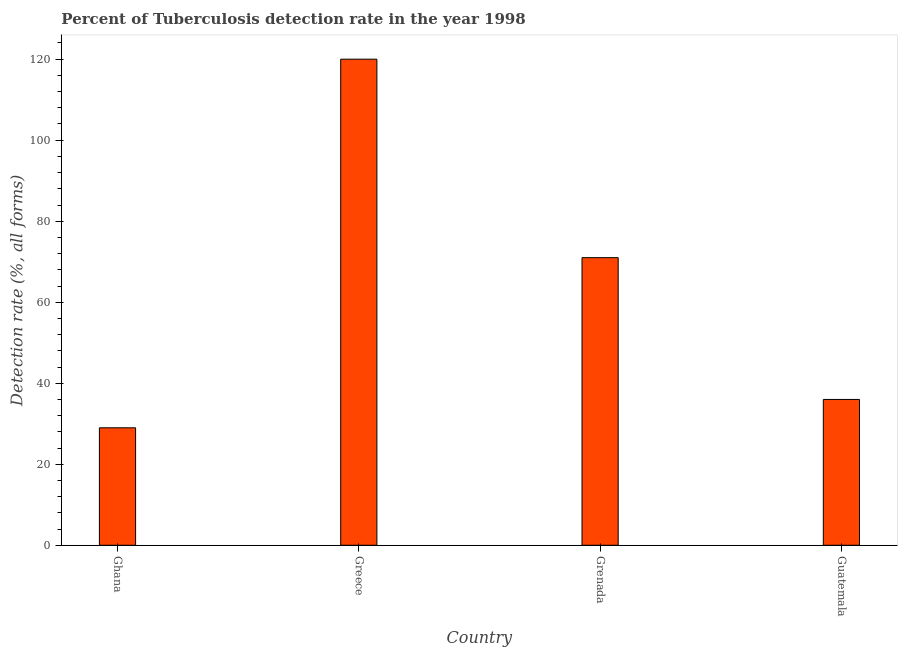Does the graph contain grids?
Your answer should be very brief. No. What is the title of the graph?
Your response must be concise. Percent of Tuberculosis detection rate in the year 1998. What is the label or title of the Y-axis?
Offer a terse response. Detection rate (%, all forms). What is the detection rate of tuberculosis in Greece?
Offer a very short reply. 120. Across all countries, what is the maximum detection rate of tuberculosis?
Keep it short and to the point. 120. In which country was the detection rate of tuberculosis maximum?
Provide a succinct answer. Greece. In which country was the detection rate of tuberculosis minimum?
Ensure brevity in your answer.  Ghana. What is the sum of the detection rate of tuberculosis?
Your answer should be very brief. 256. What is the average detection rate of tuberculosis per country?
Your answer should be compact. 64. What is the median detection rate of tuberculosis?
Provide a short and direct response. 53.5. What is the ratio of the detection rate of tuberculosis in Grenada to that in Guatemala?
Your answer should be compact. 1.97. Is the difference between the detection rate of tuberculosis in Greece and Guatemala greater than the difference between any two countries?
Give a very brief answer. No. Is the sum of the detection rate of tuberculosis in Grenada and Guatemala greater than the maximum detection rate of tuberculosis across all countries?
Provide a succinct answer. No. What is the difference between the highest and the lowest detection rate of tuberculosis?
Your answer should be compact. 91. In how many countries, is the detection rate of tuberculosis greater than the average detection rate of tuberculosis taken over all countries?
Your response must be concise. 2. How many countries are there in the graph?
Keep it short and to the point. 4. What is the difference between two consecutive major ticks on the Y-axis?
Make the answer very short. 20. Are the values on the major ticks of Y-axis written in scientific E-notation?
Provide a short and direct response. No. What is the Detection rate (%, all forms) of Greece?
Offer a very short reply. 120. What is the difference between the Detection rate (%, all forms) in Ghana and Greece?
Make the answer very short. -91. What is the difference between the Detection rate (%, all forms) in Ghana and Grenada?
Make the answer very short. -42. What is the difference between the Detection rate (%, all forms) in Ghana and Guatemala?
Offer a terse response. -7. What is the ratio of the Detection rate (%, all forms) in Ghana to that in Greece?
Your response must be concise. 0.24. What is the ratio of the Detection rate (%, all forms) in Ghana to that in Grenada?
Offer a terse response. 0.41. What is the ratio of the Detection rate (%, all forms) in Ghana to that in Guatemala?
Your answer should be compact. 0.81. What is the ratio of the Detection rate (%, all forms) in Greece to that in Grenada?
Provide a succinct answer. 1.69. What is the ratio of the Detection rate (%, all forms) in Greece to that in Guatemala?
Provide a short and direct response. 3.33. What is the ratio of the Detection rate (%, all forms) in Grenada to that in Guatemala?
Ensure brevity in your answer.  1.97. 